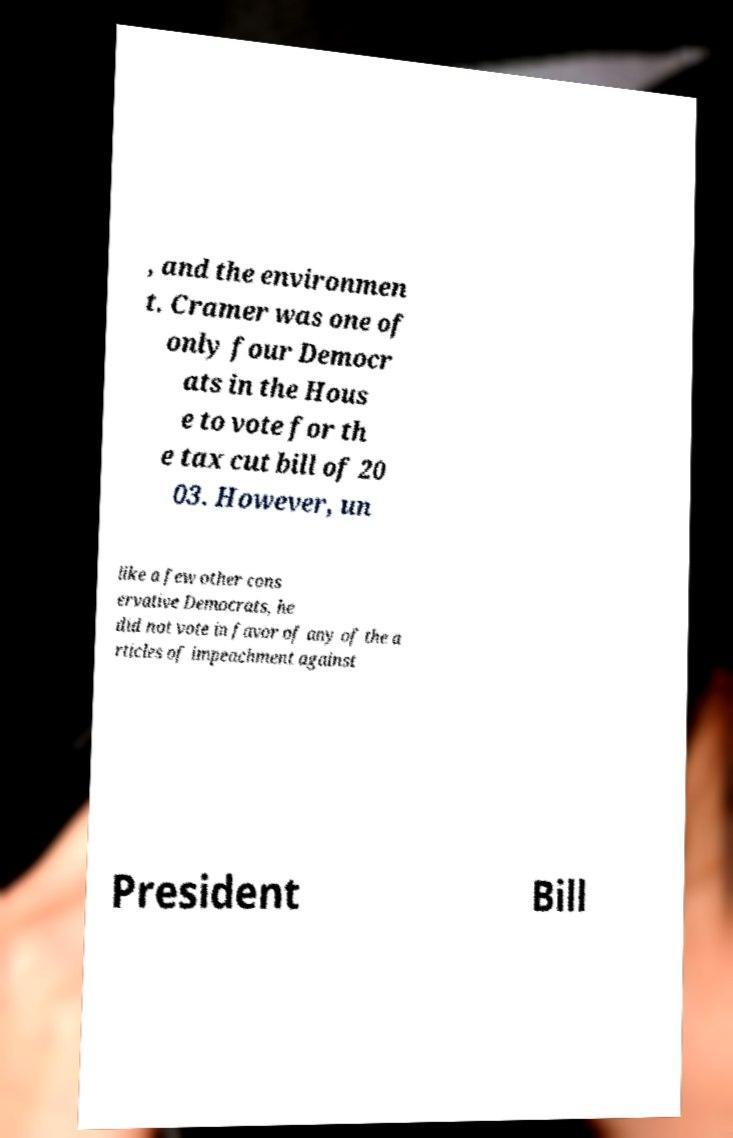Please read and relay the text visible in this image. What does it say? , and the environmen t. Cramer was one of only four Democr ats in the Hous e to vote for th e tax cut bill of 20 03. However, un like a few other cons ervative Democrats, he did not vote in favor of any of the a rticles of impeachment against President Bill 